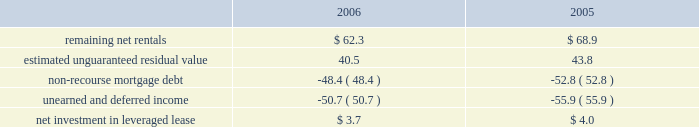Kimco realty corporation and subsidiaries job title kimco realty ar revision 6 serial date / time tuesday , april 03 , 2007 /10:32 pm job number 142704 type current page no .
65 operator pm2 <12345678> at december 31 , 2006 and 2005 , the company 2019s net invest- ment in the leveraged lease consisted of the following ( in mil- lions ) : .
Mortgages and other financing receivables : during january 2006 , the company provided approximately $ 16.0 million as its share of a $ 50.0 million junior participation in a $ 700.0 million first mortgage loan , in connection with a private investment firm 2019s acquisition of a retailer .
This loan participation bore interest at libor plus 7.75% ( 7.75 % ) per annum and had a two-year term with a one-year extension option and was collateralized by certain real estate interests of the retailer .
During june 2006 , the borrower elected to pre-pay the outstanding loan balance of approximately $ 16.0 million in full satisfaction of this loan .
Additionally , during january 2006 , the company provided approximately $ 5.2 million as its share of an $ 11.5 million term loan to a real estate developer for the acquisition of a 59 acre land parcel located in san antonio , tx .
This loan is interest only at a fixed rate of 11.0% ( 11.0 % ) for a term of two years payable monthly and collateralized by a first mortgage on the subject property .
As of december 31 , 2006 , the outstanding balance on this loan was approximately $ 5.2 million .
During february 2006 , the company committed to provide a one year $ 17.2 million credit facility at a fixed rate of 8.0% ( 8.0 % ) for a term of nine months and 9.0% ( 9.0 % ) for the remaining term to a real estate investor for the recapitalization of a discount and entertain- ment mall that it currently owns .
During 2006 , this facility was fully paid and was terminated .
During april 2006 , the company provided two separate mortgages aggregating $ 14.5 million on a property owned by a real estate investor .
Proceeds were used to payoff the existing first mortgage , buyout the existing partner and for redevelopment of the property .
The mortgages bear interest at 8.0% ( 8.0 % ) per annum and mature in 2008 and 2013 .
These mortgages are collateralized by the subject property .
As of december 31 , 2006 , the aggregate outstanding balance on these mortgages was approximately $ 15.0 million , including $ 0.5 million of accrued interest .
During may 2006 , the company provided a cad $ 23.5 million collateralized credit facility at a fixed rate of 8.5% ( 8.5 % ) per annum for a term of two years to a real estate company for the execution of its property acquisitions program .
The credit facility is guaranteed by the real estate company .
The company was issued 9811 units , valued at approximately usd $ 0.1 million , and warrants to purchase up to 0.1 million shares of the real estate company as a loan origination fee .
During august 2006 , the company increased the credit facility to cad $ 45.0 million and received an additional 9811 units , valued at approximately usd $ 0.1 million , and warrants to purchase up to 0.1 million shares of the real estate company .
As of december 31 , 2006 , the outstand- ing balance on this credit facility was approximately cad $ 3.6 million ( approximately usd $ 3.1 million ) .
During september 2005 , a newly formed joint venture , in which the company had an 80% ( 80 % ) interest , acquired a 90% ( 90 % ) interest in a $ 48.4 million mortgage receivable for a purchase price of approximately $ 34.2 million .
This loan bore interest at a rate of three-month libor plus 2.75% ( 2.75 % ) per annum and was scheduled to mature on january 12 , 2010 .
A 626-room hotel located in lake buena vista , fl collateralized the loan .
The company had determined that this joint venture entity was a vie and had further determined that the company was the primary benefici- ary of this vie and had therefore consolidated it for financial reporting purposes .
During march 2006 , the joint venture acquired the remaining 10% ( 10 % ) of this mortgage receivable for a purchase price of approximately $ 3.8 million .
During june 2006 , the joint venture accepted a pre-payment of approximately $ 45.2 million from the borrower as full satisfaction of this loan .
During august 2006 , the company provided $ 8.8 million as its share of a $ 13.2 million 12-month term loan to a retailer for general corporate purposes .
This loan bears interest at a fixed rate of 12.50% ( 12.50 % ) with interest payable monthly and a balloon payment for the principal balance at maturity .
The loan is collateralized by the underlying real estate of the retailer .
Additionally , the company funded $ 13.3 million as its share of a $ 20.0 million revolving debtor-in-possession facility to this retailer .
The facility bears interest at libor plus 3.00% ( 3.00 % ) and has an unused line fee of 0.375% ( 0.375 % ) .
This credit facility is collateralized by a first priority lien on all the retailer 2019s assets .
As of december 31 , 2006 , the compa- ny 2019s share of the outstanding balance on this loan and credit facility was approximately $ 7.6 million and $ 4.9 million , respec- tively .
During september 2006 , the company provided a mxp 57.3 million ( approximately usd $ 5.3 million ) loan to an owner of an operating property in mexico .
The loan , which is collateralized by the property , bears interest at 12.0% ( 12.0 % ) per annum and matures in 2016 .
The company is entitled to a participation feature of 25% ( 25 % ) of annual cash flows after debt service and 20% ( 20 % ) of the gain on sale of the property .
As of december 31 , 2006 , the outstand- ing balance on this loan was approximately mxp 57.8 million ( approximately usd $ 5.3 million ) .
During november 2006 , the company committed to provide a mxp 124.8 million ( approximately usd $ 11.5 million ) loan to an owner of a land parcel in acapulco , mexico .
The loan , which is collateralized with an operating property owned by the bor- rower , bears interest at 10% ( 10 % ) per annum and matures in 2016 .
The company is entitled to a participation feature of 20% ( 20 % ) of excess cash flows and gains on sale of the property .
As of decem- ber 31 , 2006 , the outstanding balance on this loan was mxp 12.8 million ( approximately usd $ 1.2 million ) . .
What is the currency exchange rate cad to usd used to convert the value of the outstanding credit facility as of december 31 , 3006? 
Computations: (3.6 / 3.1)
Answer: 1.16129. 